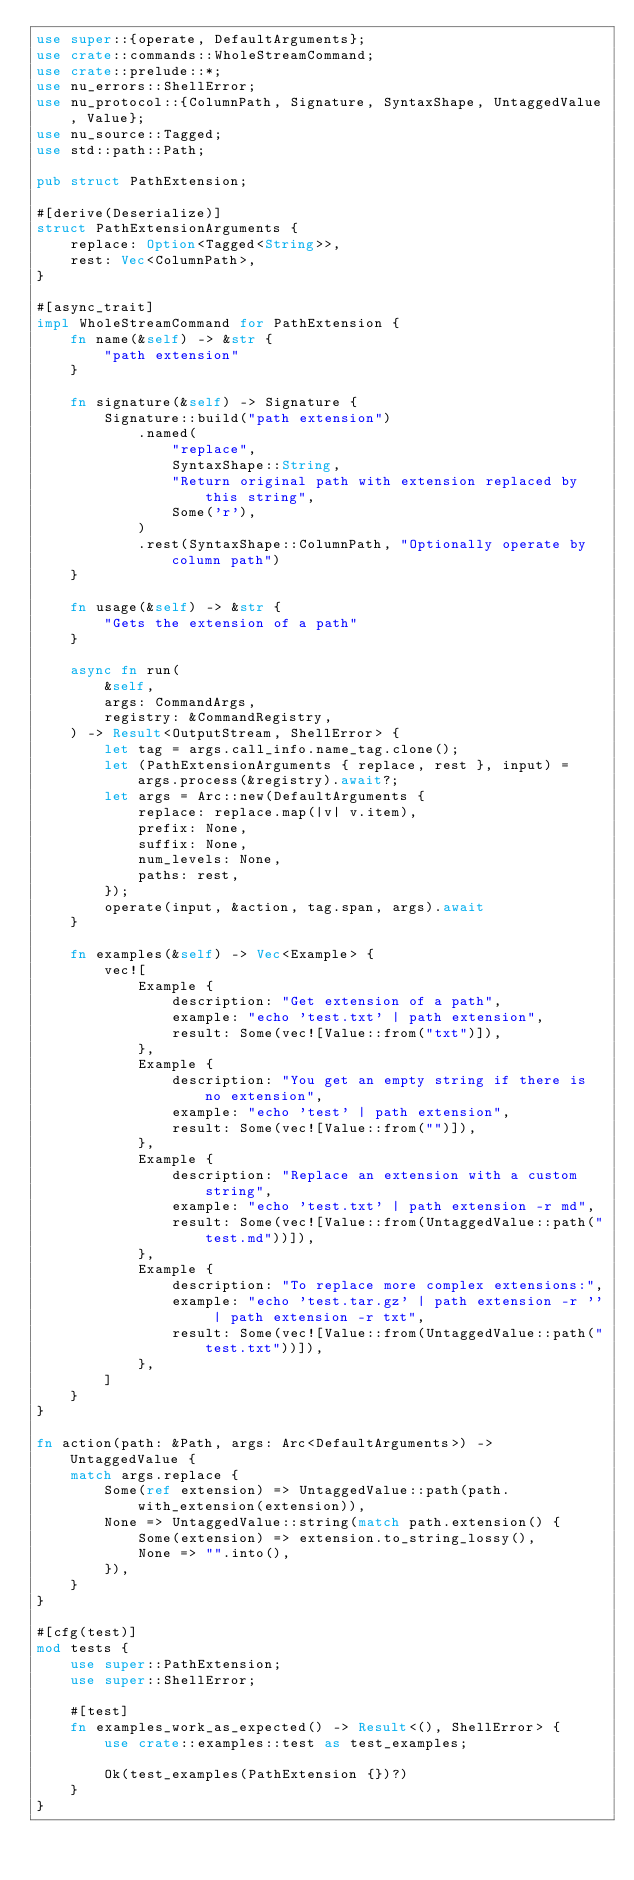<code> <loc_0><loc_0><loc_500><loc_500><_Rust_>use super::{operate, DefaultArguments};
use crate::commands::WholeStreamCommand;
use crate::prelude::*;
use nu_errors::ShellError;
use nu_protocol::{ColumnPath, Signature, SyntaxShape, UntaggedValue, Value};
use nu_source::Tagged;
use std::path::Path;

pub struct PathExtension;

#[derive(Deserialize)]
struct PathExtensionArguments {
    replace: Option<Tagged<String>>,
    rest: Vec<ColumnPath>,
}

#[async_trait]
impl WholeStreamCommand for PathExtension {
    fn name(&self) -> &str {
        "path extension"
    }

    fn signature(&self) -> Signature {
        Signature::build("path extension")
            .named(
                "replace",
                SyntaxShape::String,
                "Return original path with extension replaced by this string",
                Some('r'),
            )
            .rest(SyntaxShape::ColumnPath, "Optionally operate by column path")
    }

    fn usage(&self) -> &str {
        "Gets the extension of a path"
    }

    async fn run(
        &self,
        args: CommandArgs,
        registry: &CommandRegistry,
    ) -> Result<OutputStream, ShellError> {
        let tag = args.call_info.name_tag.clone();
        let (PathExtensionArguments { replace, rest }, input) = args.process(&registry).await?;
        let args = Arc::new(DefaultArguments {
            replace: replace.map(|v| v.item),
            prefix: None,
            suffix: None,
            num_levels: None,
            paths: rest,
        });
        operate(input, &action, tag.span, args).await
    }

    fn examples(&self) -> Vec<Example> {
        vec![
            Example {
                description: "Get extension of a path",
                example: "echo 'test.txt' | path extension",
                result: Some(vec![Value::from("txt")]),
            },
            Example {
                description: "You get an empty string if there is no extension",
                example: "echo 'test' | path extension",
                result: Some(vec![Value::from("")]),
            },
            Example {
                description: "Replace an extension with a custom string",
                example: "echo 'test.txt' | path extension -r md",
                result: Some(vec![Value::from(UntaggedValue::path("test.md"))]),
            },
            Example {
                description: "To replace more complex extensions:",
                example: "echo 'test.tar.gz' | path extension -r '' | path extension -r txt",
                result: Some(vec![Value::from(UntaggedValue::path("test.txt"))]),
            },
        ]
    }
}

fn action(path: &Path, args: Arc<DefaultArguments>) -> UntaggedValue {
    match args.replace {
        Some(ref extension) => UntaggedValue::path(path.with_extension(extension)),
        None => UntaggedValue::string(match path.extension() {
            Some(extension) => extension.to_string_lossy(),
            None => "".into(),
        }),
    }
}

#[cfg(test)]
mod tests {
    use super::PathExtension;
    use super::ShellError;

    #[test]
    fn examples_work_as_expected() -> Result<(), ShellError> {
        use crate::examples::test as test_examples;

        Ok(test_examples(PathExtension {})?)
    }
}
</code> 